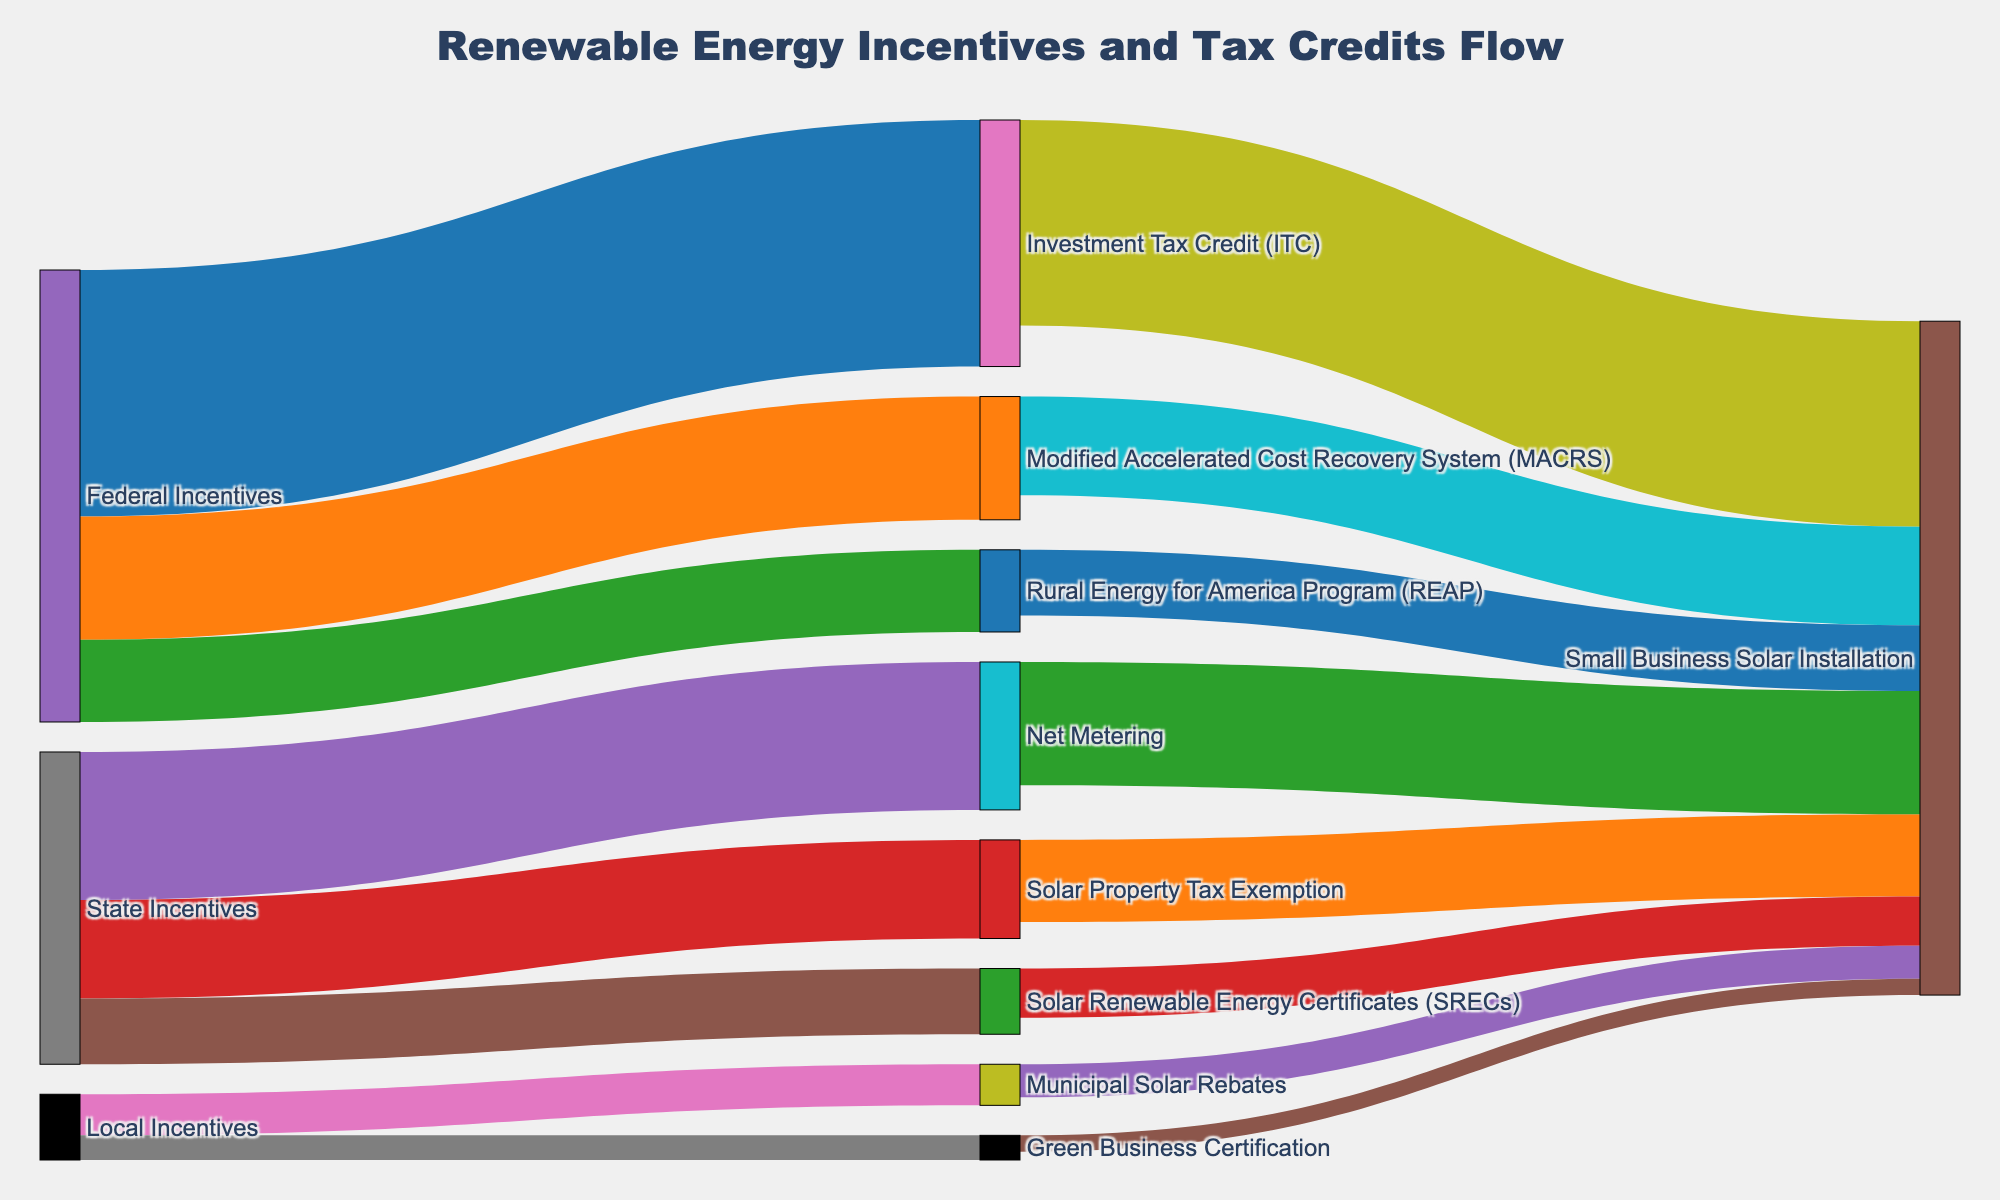what is the title of the figure? The central title of the figure is displayed prominently and is used to understand the main subject of the diagram.
Answer: Renewable Energy Incentives and Tax Credits Flow How many nodes are there in total in the Sankey Diagram? To count the total number of nodes, count each unique element displayed in the figure.
Answer: 13 Which incentive program provides the highest value toward Small Business Solar Installation? Identify the different incentives and their respective values contributing to Small Business Solar Installation. Compare these values to find the highest one.
Answer: Investment Tax Credit (ITC) What's the sum of values coming from State Incentives? Add up the values directed from the "State Incentives" node to other nodes (Solar Property Tax Exemption, Net Metering, and SRECs).
Answer: 38 Is the contribution from Local Incentives greater than that from Federal Incentives to Small Business Solar Installation? Calculate the total value from Local Incentives and Federal Incentives towards Small Business Solar Installation and compare them.
Answer: No What is the combined value directed from the Investment Tax Credit (ITC) and the Modified Accelerated Cost Recovery System (MACRS) to Small Business Solar Installation? Add the values directed from ITC and MACRS to Small Business Solar Installation.
Answer: 37 Which node has the smallest value directed towards Small Business Solar Installation? Examine all nodes directing flow towards Small Business Solar Installation and identify the node with the smallest value.
Answer: Green Business Certification What's the difference in value between Net Metering and Solar Property Tax Exemption towards Small Business Solar Installation? Calculate the absolute difference between the values from Net Metering and Solar Property Tax Exemption to Small Business Solar Installation.
Answer: 5 How many unique types of incentives are visualized in the diagram? Count the unique categories of incentives, including Federal Incentives, State Incentives, and Local Incentives.
Answer: 3 Which incentive contributes more to Small Business Solar Installation, MACRS or Rural Energy for America Program (REAP)? Compare the values directed from MACRS and REAP towards Small Business Solar Installation.
Answer: MACRS 